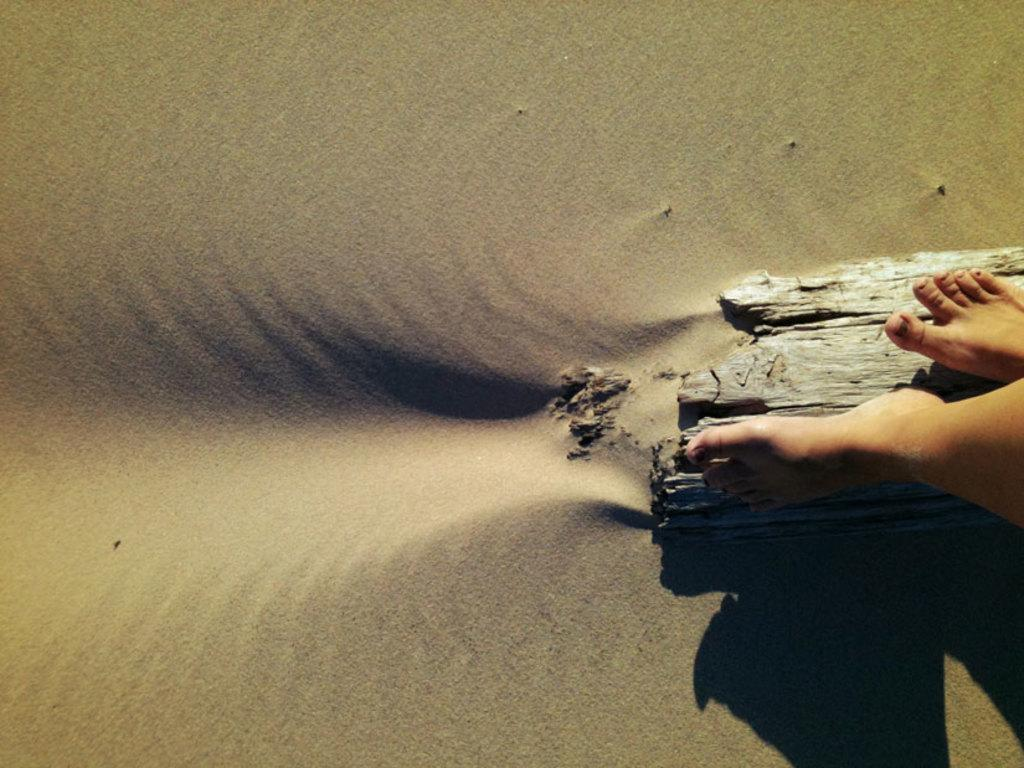What body parts can be seen in the image? There are persons' legs visible in the image. What type of surface is at the bottom of the image? There is sand at the bottom of the image. How does the ocean affect the crib in the image? There is no ocean or crib present in the image. 